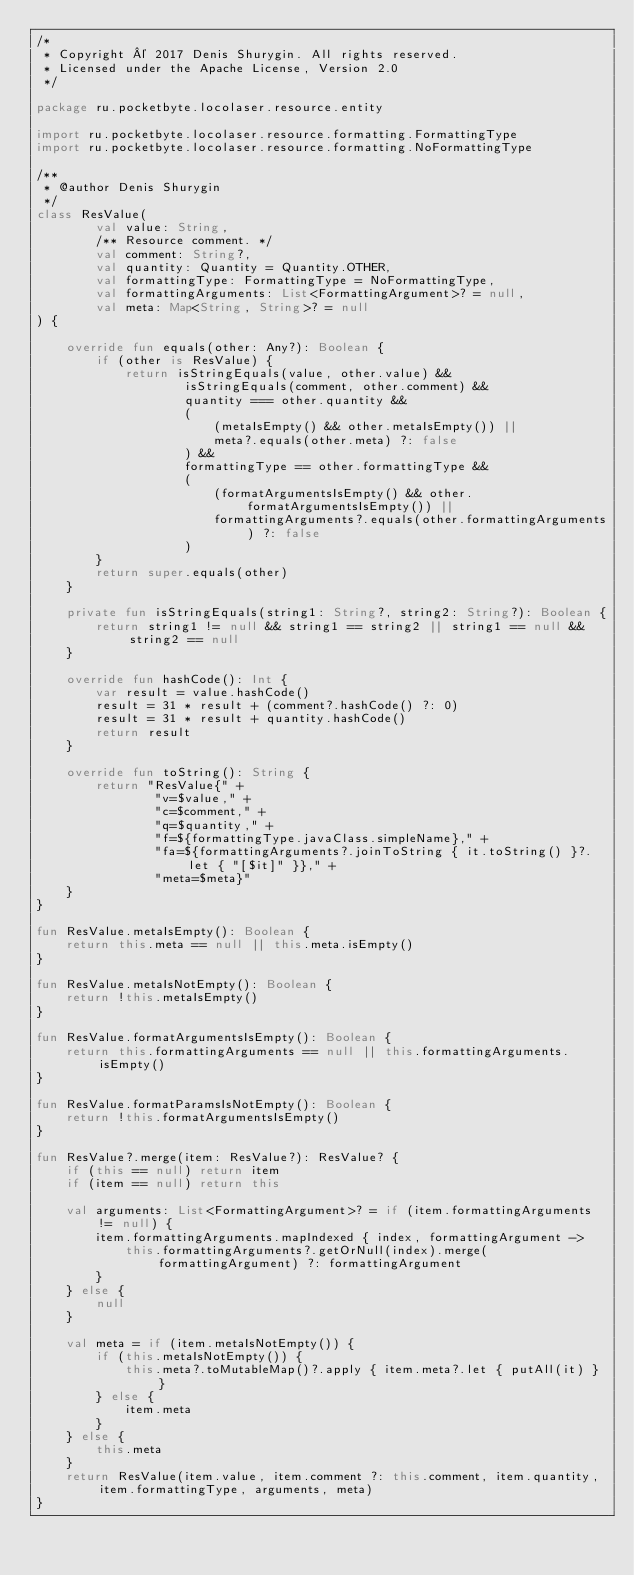Convert code to text. <code><loc_0><loc_0><loc_500><loc_500><_Kotlin_>/*
 * Copyright © 2017 Denis Shurygin. All rights reserved.
 * Licensed under the Apache License, Version 2.0
 */

package ru.pocketbyte.locolaser.resource.entity

import ru.pocketbyte.locolaser.resource.formatting.FormattingType
import ru.pocketbyte.locolaser.resource.formatting.NoFormattingType

/**
 * @author Denis Shurygin
 */
class ResValue(
        val value: String,
        /** Resource comment. */
        val comment: String?,
        val quantity: Quantity = Quantity.OTHER,
        val formattingType: FormattingType = NoFormattingType,
        val formattingArguments: List<FormattingArgument>? = null,
        val meta: Map<String, String>? = null
) {

    override fun equals(other: Any?): Boolean {
        if (other is ResValue) {
            return isStringEquals(value, other.value) &&
                    isStringEquals(comment, other.comment) &&
                    quantity === other.quantity &&
                    (
                        (metaIsEmpty() && other.metaIsEmpty()) ||
                        meta?.equals(other.meta) ?: false
                    ) &&
                    formattingType == other.formattingType &&
                    (
                        (formatArgumentsIsEmpty() && other.formatArgumentsIsEmpty()) ||
                        formattingArguments?.equals(other.formattingArguments) ?: false
                    )
        }
        return super.equals(other)
    }

    private fun isStringEquals(string1: String?, string2: String?): Boolean {
        return string1 != null && string1 == string2 || string1 == null && string2 == null
    }

    override fun hashCode(): Int {
        var result = value.hashCode()
        result = 31 * result + (comment?.hashCode() ?: 0)
        result = 31 * result + quantity.hashCode()
        return result
    }

    override fun toString(): String {
        return "ResValue{" +
                "v=$value," +
                "c=$comment," +
                "q=$quantity," +
                "f=${formattingType.javaClass.simpleName}," +
                "fa=${formattingArguments?.joinToString { it.toString() }?.let { "[$it]" }}," +
                "meta=$meta}"
    }
}

fun ResValue.metaIsEmpty(): Boolean {
    return this.meta == null || this.meta.isEmpty()
}

fun ResValue.metaIsNotEmpty(): Boolean {
    return !this.metaIsEmpty()
}

fun ResValue.formatArgumentsIsEmpty(): Boolean {
    return this.formattingArguments == null || this.formattingArguments.isEmpty()
}

fun ResValue.formatParamsIsNotEmpty(): Boolean {
    return !this.formatArgumentsIsEmpty()
}

fun ResValue?.merge(item: ResValue?): ResValue? {
    if (this == null) return item
    if (item == null) return this

    val arguments: List<FormattingArgument>? = if (item.formattingArguments != null) {
        item.formattingArguments.mapIndexed { index, formattingArgument ->
            this.formattingArguments?.getOrNull(index).merge(formattingArgument) ?: formattingArgument
        }
    } else {
        null
    }

    val meta = if (item.metaIsNotEmpty()) {
        if (this.metaIsNotEmpty()) {
            this.meta?.toMutableMap()?.apply { item.meta?.let { putAll(it) } }
        } else {
            item.meta
        }
    } else {
        this.meta
    }
    return ResValue(item.value, item.comment ?: this.comment, item.quantity, item.formattingType, arguments, meta)
}</code> 